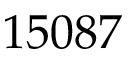<formula> <loc_0><loc_0><loc_500><loc_500>1 5 0 8 7</formula> 